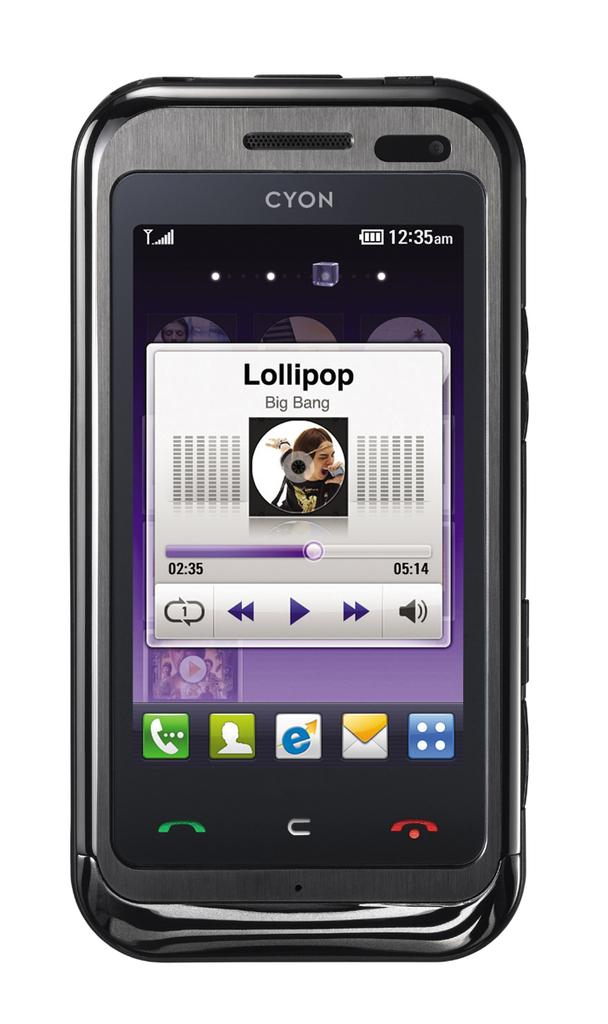<image>
Give a short and clear explanation of the subsequent image. A CYON cell phone playing Lollipop by the artist Big Bang. 